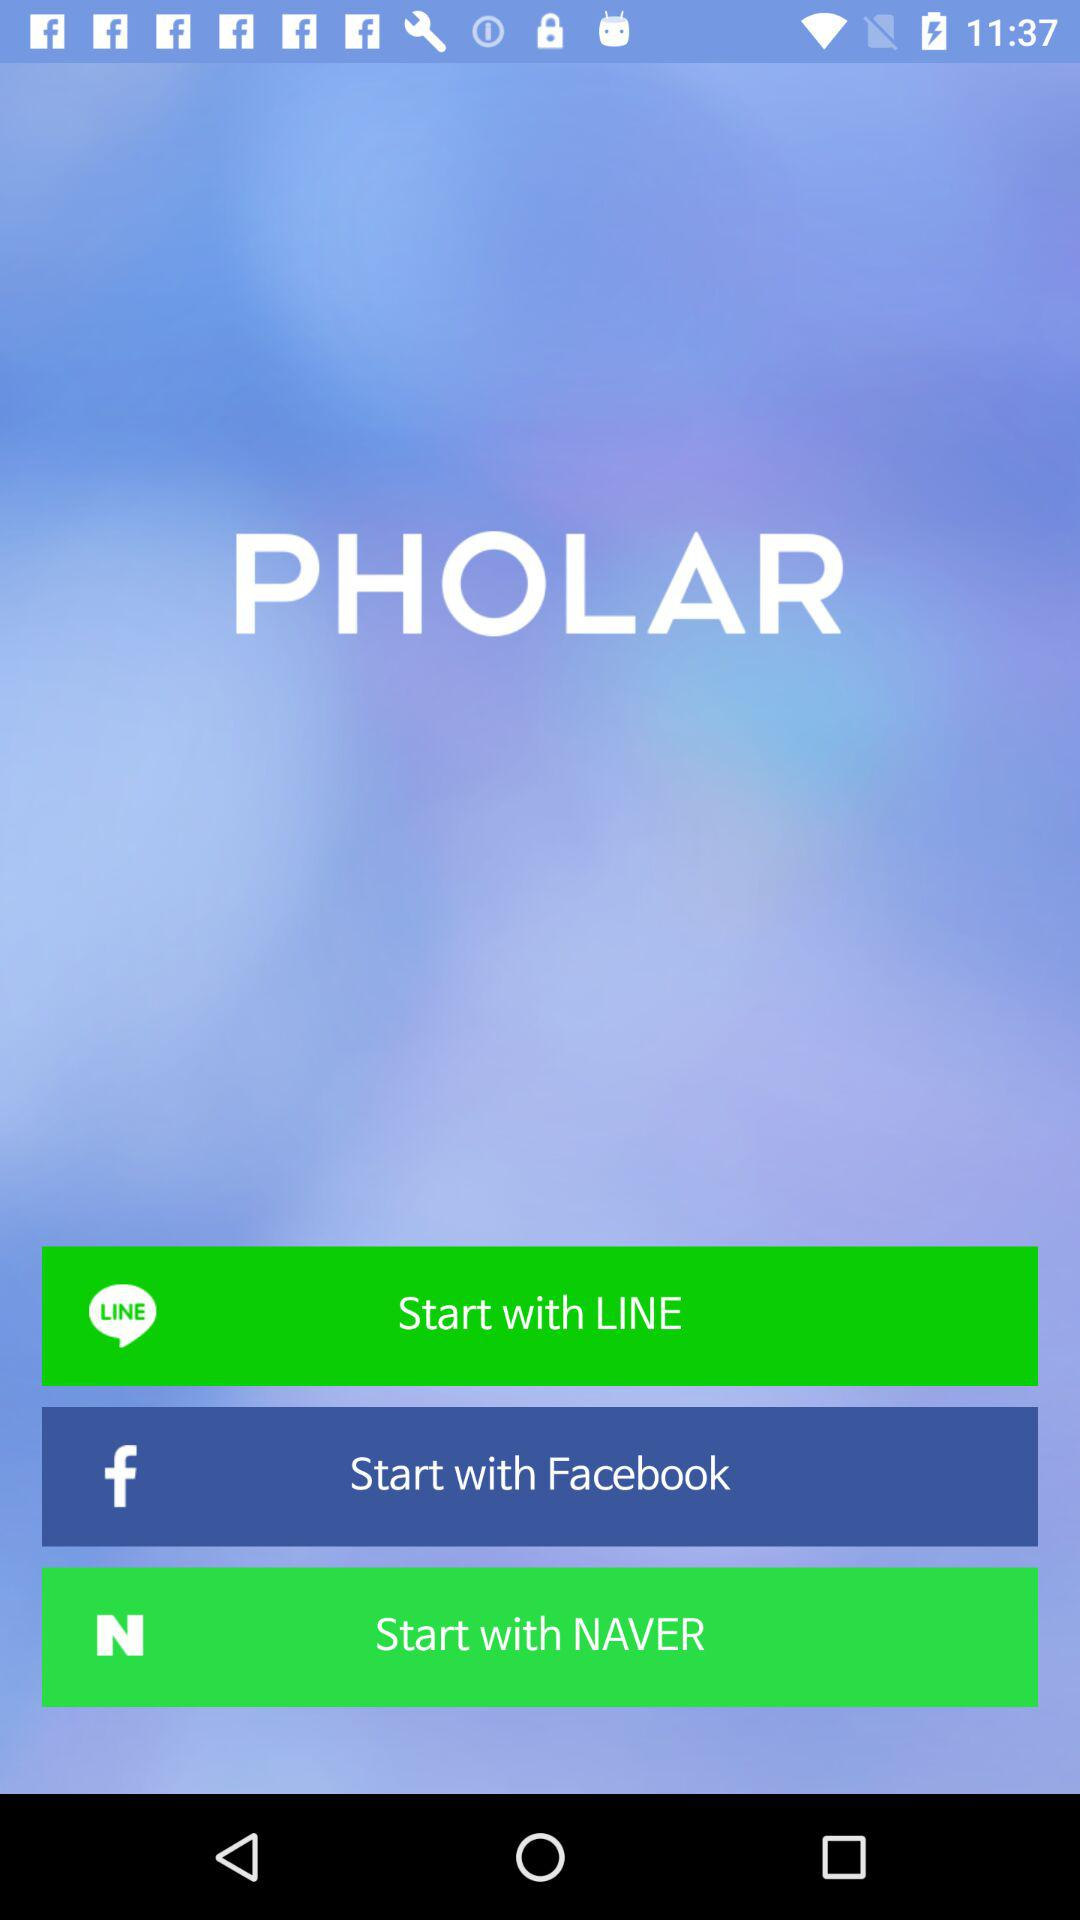What accounts can I use to log in? You can use "LINE", "Facebook", and "NAVER" to log in. 